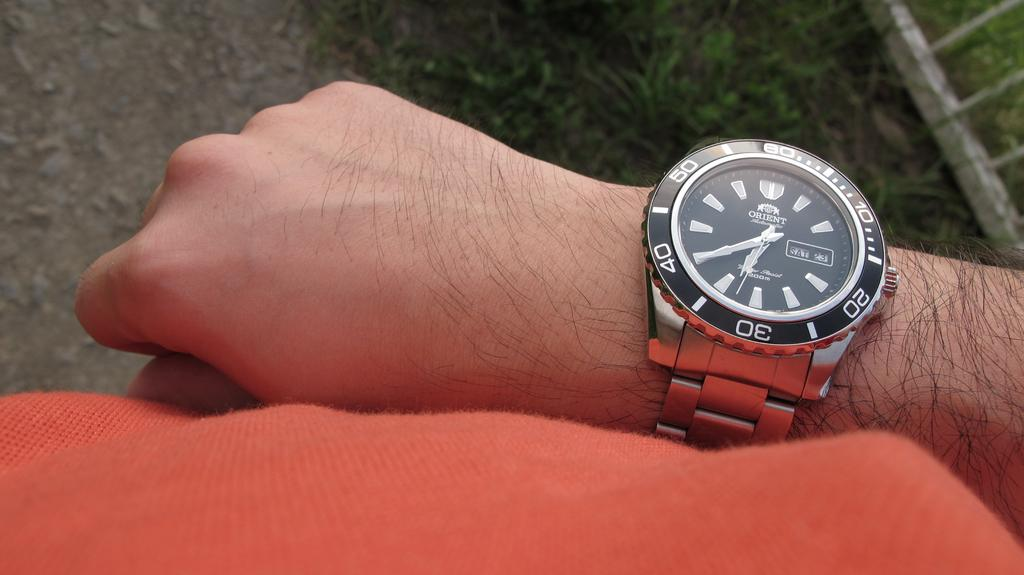<image>
Give a short and clear explanation of the subsequent image. A black Orient brand watch that shows SAT 23 on it. 